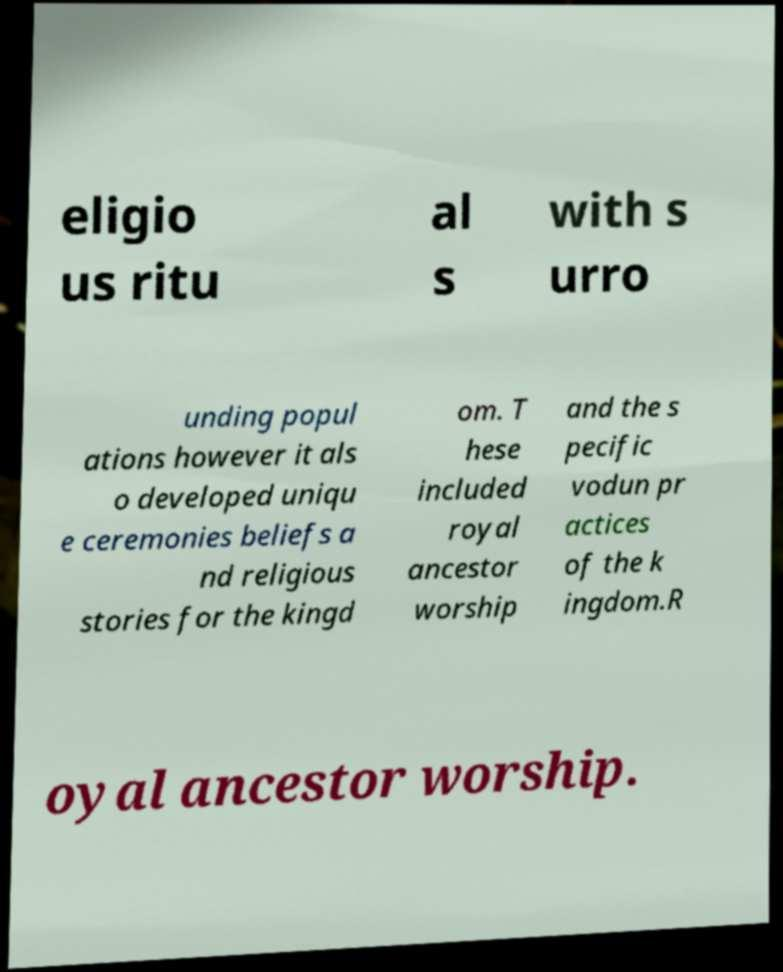Can you accurately transcribe the text from the provided image for me? eligio us ritu al s with s urro unding popul ations however it als o developed uniqu e ceremonies beliefs a nd religious stories for the kingd om. T hese included royal ancestor worship and the s pecific vodun pr actices of the k ingdom.R oyal ancestor worship. 